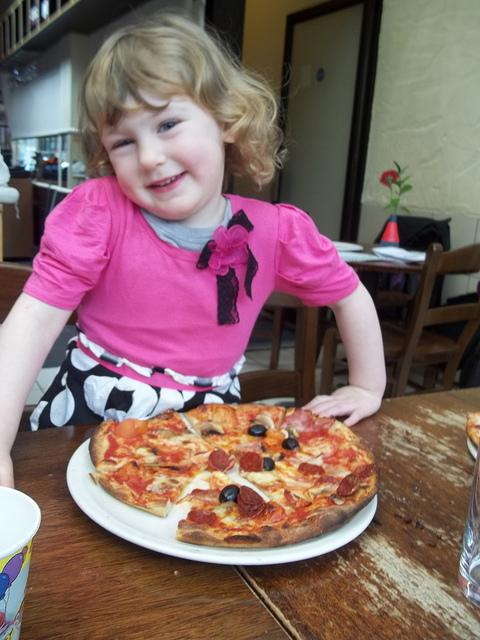What fruit might this person eat first? tomato 